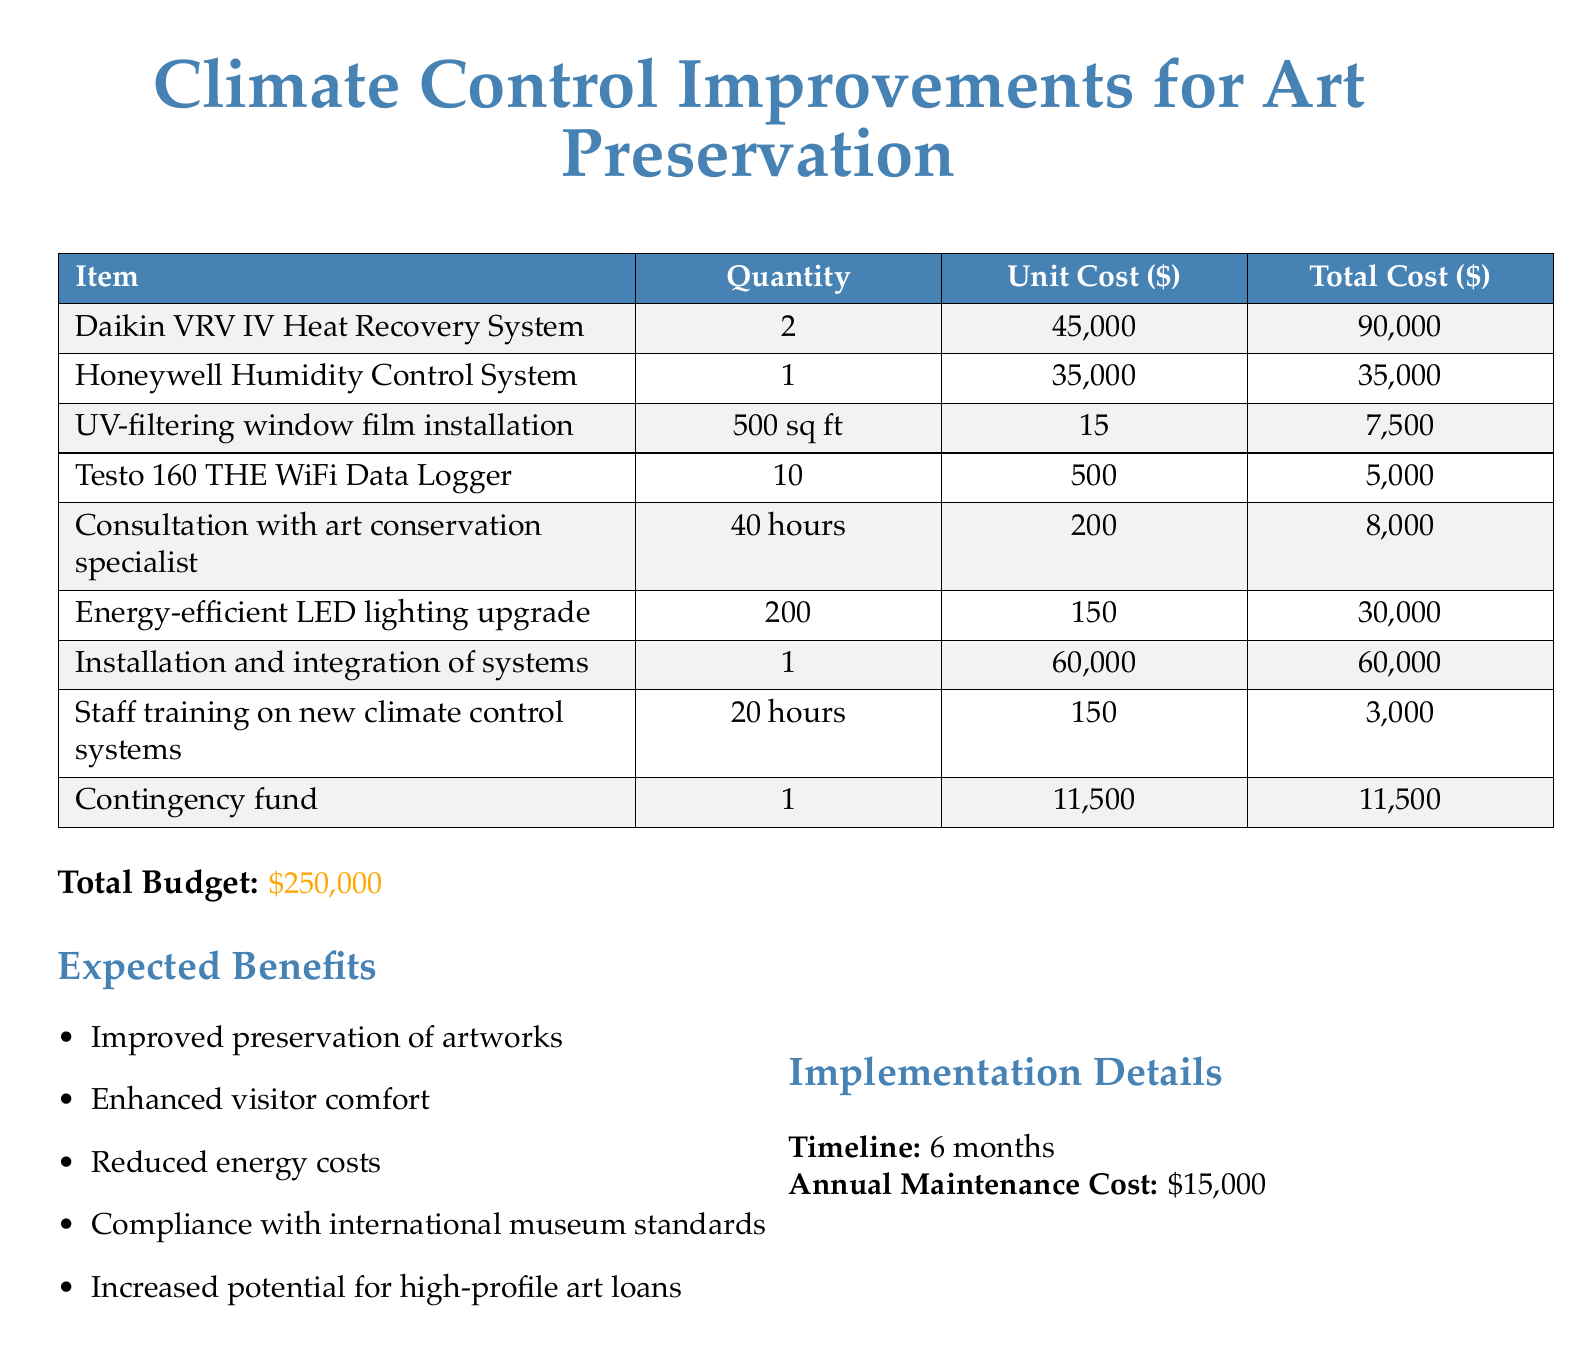What is the total cost for the Daikin VRV IV Heat Recovery System? The total cost for the Daikin VRV IV Heat Recovery System is listed in the table as $90,000.
Answer: $90,000 How many hours are allocated for staff training on new climate control systems? The document states that 20 hours are allocated for staff training on new climate control systems.
Answer: 20 hours What is the unit cost of the Honeywell Humidity Control System? The unit cost of the Honeywell Humidity Control System is listed as $35,000 in the table.
Answer: $35,000 What is the total budget for the project? The document clearly states that the total budget for the project is $250,000.
Answer: $250,000 How many Daikin VRV IV Heat Recovery Systems are budgeted for purchase? The table indicates that 2 Daikin VRV IV Heat Recovery Systems are budgeted for purchase.
Answer: 2 What is the annual maintenance cost outlined in the document? The document specifies that the annual maintenance cost is $15,000.
Answer: $15,000 What are the expected benefits of the climate control improvements? The document lists benefits such as improved preservation of artworks and enhanced visitor comfort.
Answer: Improved preservation of artworks What is the contingency fund amount? The contingency fund amount is specified in the budget table as $11,500.
Answer: $11,500 How long is the timeline for implementation? The document states that the timeline for implementation is 6 months.
Answer: 6 months 